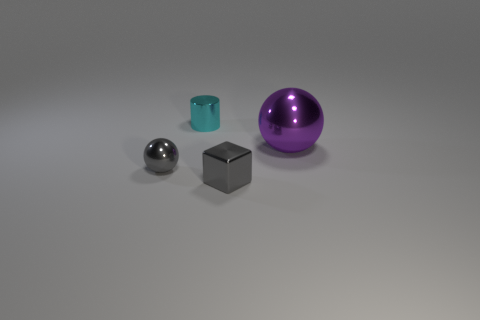Add 4 small gray spheres. How many objects exist? 8 Subtract all cylinders. How many objects are left? 3 Subtract 1 gray spheres. How many objects are left? 3 Subtract all gray shiny spheres. Subtract all cyan things. How many objects are left? 2 Add 3 cyan metallic objects. How many cyan metallic objects are left? 4 Add 3 purple objects. How many purple objects exist? 4 